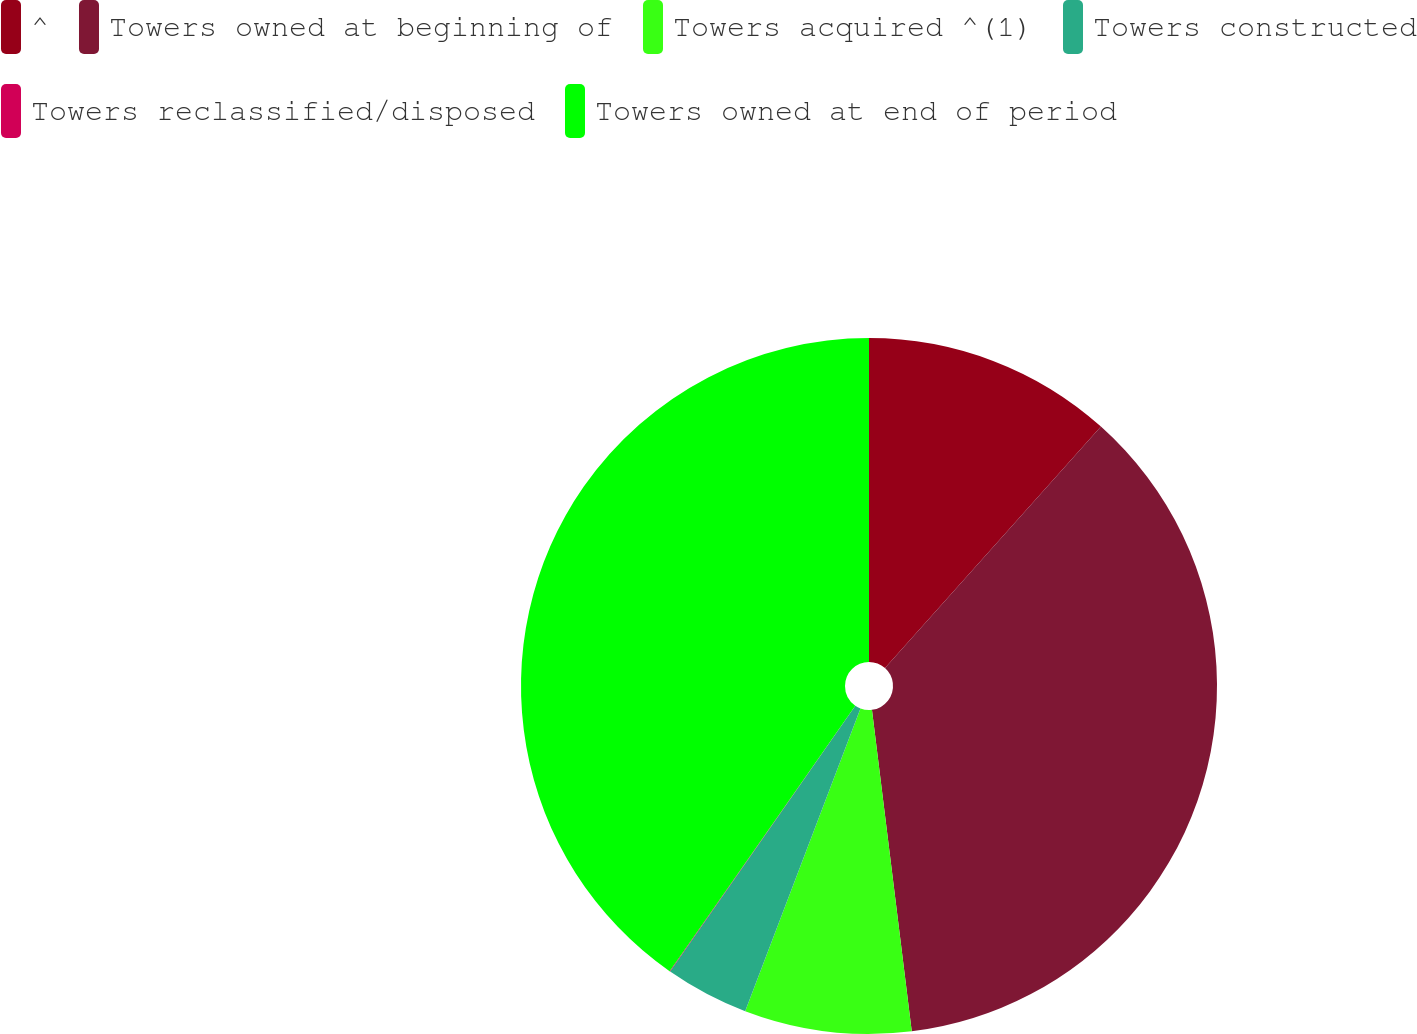Convert chart. <chart><loc_0><loc_0><loc_500><loc_500><pie_chart><fcel>^<fcel>Towers owned at beginning of<fcel>Towers acquired ^(1)<fcel>Towers constructed<fcel>Towers reclassified/disposed<fcel>Towers owned at end of period<nl><fcel>11.61%<fcel>36.43%<fcel>7.75%<fcel>3.89%<fcel>0.03%<fcel>40.29%<nl></chart> 